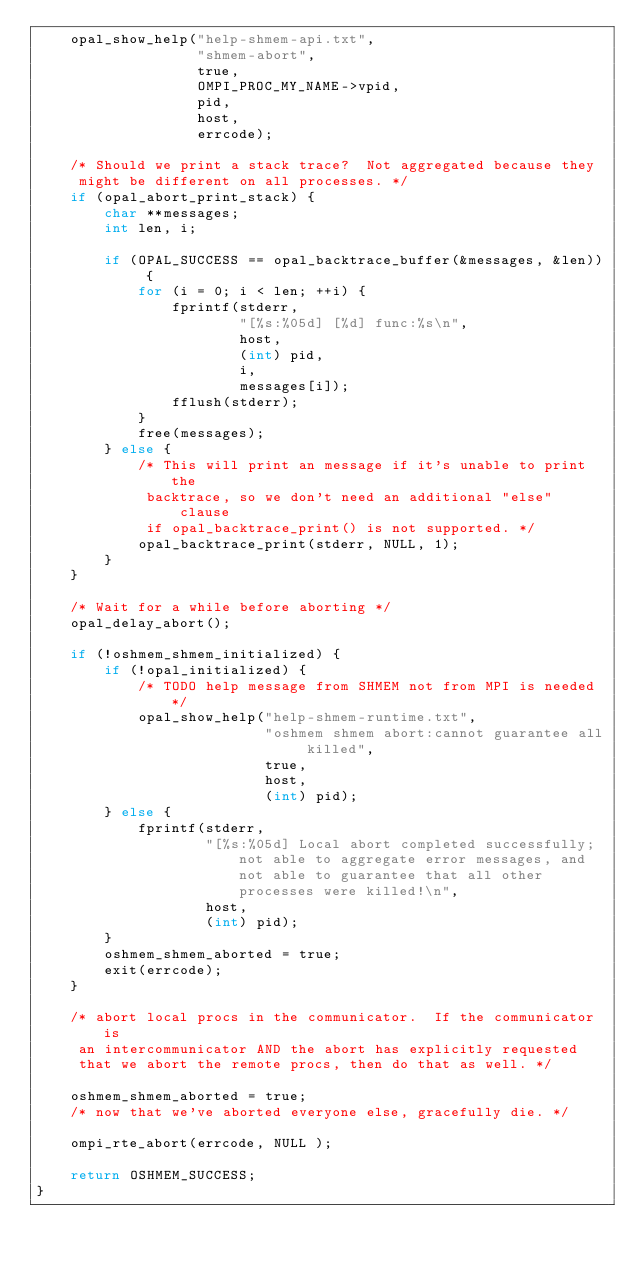<code> <loc_0><loc_0><loc_500><loc_500><_C_>    opal_show_help("help-shmem-api.txt",
                   "shmem-abort",
                   true,
                   OMPI_PROC_MY_NAME->vpid,
                   pid,
                   host,
                   errcode);

    /* Should we print a stack trace?  Not aggregated because they
     might be different on all processes. */
    if (opal_abort_print_stack) {
        char **messages;
        int len, i;

        if (OPAL_SUCCESS == opal_backtrace_buffer(&messages, &len)) {
            for (i = 0; i < len; ++i) {
                fprintf(stderr,
                        "[%s:%05d] [%d] func:%s\n",
                        host,
                        (int) pid,
                        i,
                        messages[i]);
                fflush(stderr);
            }
            free(messages);
        } else {
            /* This will print an message if it's unable to print the
             backtrace, so we don't need an additional "else" clause
             if opal_backtrace_print() is not supported. */
            opal_backtrace_print(stderr, NULL, 1);
        }
    }

    /* Wait for a while before aborting */
    opal_delay_abort();

    if (!oshmem_shmem_initialized) {
        if (!opal_initialized) {
            /* TODO help message from SHMEM not from MPI is needed*/
            opal_show_help("help-shmem-runtime.txt",
                           "oshmem shmem abort:cannot guarantee all killed",
                           true,
                           host,
                           (int) pid);
        } else {
            fprintf(stderr,
                    "[%s:%05d] Local abort completed successfully; not able to aggregate error messages, and not able to guarantee that all other processes were killed!\n",
                    host,
                    (int) pid);
        }
        oshmem_shmem_aborted = true;
        exit(errcode);
    }

    /* abort local procs in the communicator.  If the communicator is
     an intercommunicator AND the abort has explicitly requested
     that we abort the remote procs, then do that as well. */

    oshmem_shmem_aborted = true;
    /* now that we've aborted everyone else, gracefully die. */

    ompi_rte_abort(errcode, NULL );

    return OSHMEM_SUCCESS;
}
</code> 